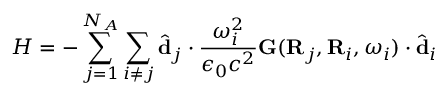Convert formula to latex. <formula><loc_0><loc_0><loc_500><loc_500>H = - \sum _ { j = 1 } ^ { N _ { A } } \sum _ { i \neq j } \hat { d } _ { j } \cdot \frac { \omega _ { i } ^ { 2 } } { \epsilon _ { 0 } c ^ { 2 } } G ( R _ { j } , R _ { i } , \omega _ { i } ) \cdot \hat { d } _ { i }</formula> 